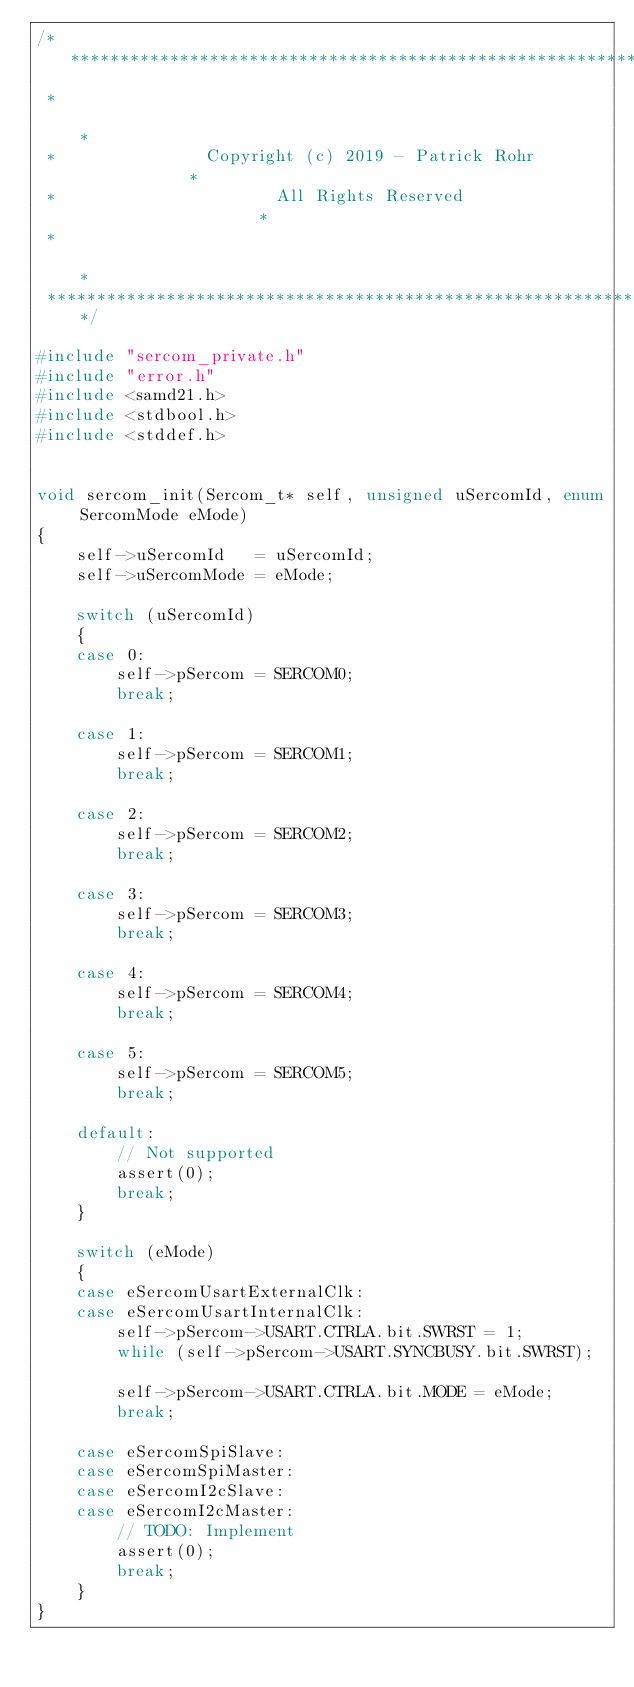Convert code to text. <code><loc_0><loc_0><loc_500><loc_500><_C_>/**************************************************************
 *                                                            *
 *               Copyright (c) 2019 - Patrick Rohr            *
 *                      All Rights Reserved                   *
 *                                                            *
 *************************************************************/

#include "sercom_private.h"
#include "error.h"
#include <samd21.h>
#include <stdbool.h>
#include <stddef.h>


void sercom_init(Sercom_t* self, unsigned uSercomId, enum SercomMode eMode)
{
    self->uSercomId   = uSercomId;
    self->uSercomMode = eMode;

    switch (uSercomId)
    {
    case 0:
        self->pSercom = SERCOM0;
        break;

    case 1:
        self->pSercom = SERCOM1;
        break;

    case 2:
        self->pSercom = SERCOM2;
        break;

    case 3:
        self->pSercom = SERCOM3;
        break;

    case 4:
        self->pSercom = SERCOM4;
        break;

    case 5:
        self->pSercom = SERCOM5;
        break;

    default:
        // Not supported
        assert(0);
        break;
    }

    switch (eMode)
    {
    case eSercomUsartExternalClk:
    case eSercomUsartInternalClk:
        self->pSercom->USART.CTRLA.bit.SWRST = 1;
        while (self->pSercom->USART.SYNCBUSY.bit.SWRST);

        self->pSercom->USART.CTRLA.bit.MODE = eMode;
        break;

    case eSercomSpiSlave:
    case eSercomSpiMaster:
    case eSercomI2cSlave:
    case eSercomI2cMaster:
        // TODO: Implement
        assert(0);
        break;
    }
}
</code> 